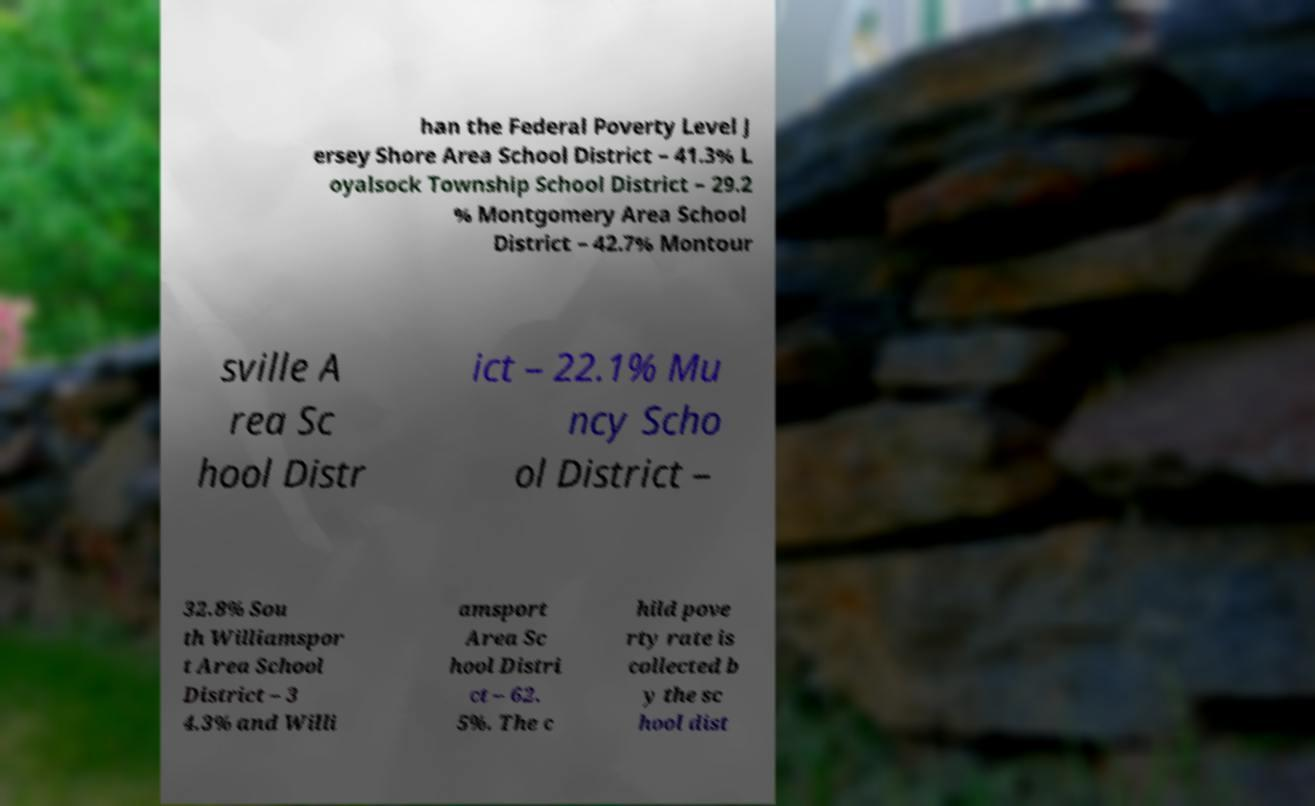For documentation purposes, I need the text within this image transcribed. Could you provide that? han the Federal Poverty Level J ersey Shore Area School District – 41.3% L oyalsock Township School District – 29.2 % Montgomery Area School District – 42.7% Montour sville A rea Sc hool Distr ict – 22.1% Mu ncy Scho ol District – 32.8% Sou th Williamspor t Area School District – 3 4.3% and Willi amsport Area Sc hool Distri ct – 62. 5%. The c hild pove rty rate is collected b y the sc hool dist 